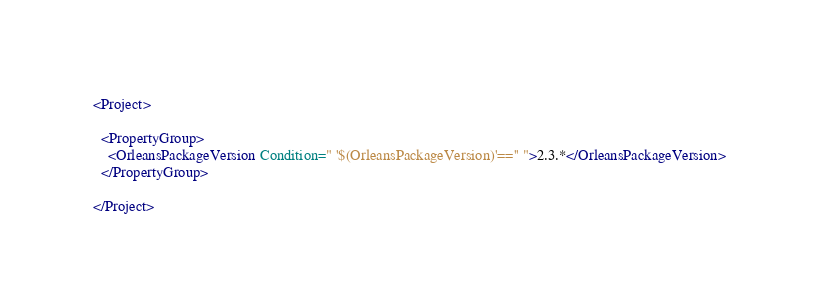Convert code to text. <code><loc_0><loc_0><loc_500><loc_500><_XML_><Project>

  <PropertyGroup>
    <OrleansPackageVersion Condition=" '$(OrleansPackageVersion)'=='' ">2.3.*</OrleansPackageVersion>
  </PropertyGroup>

</Project>
</code> 